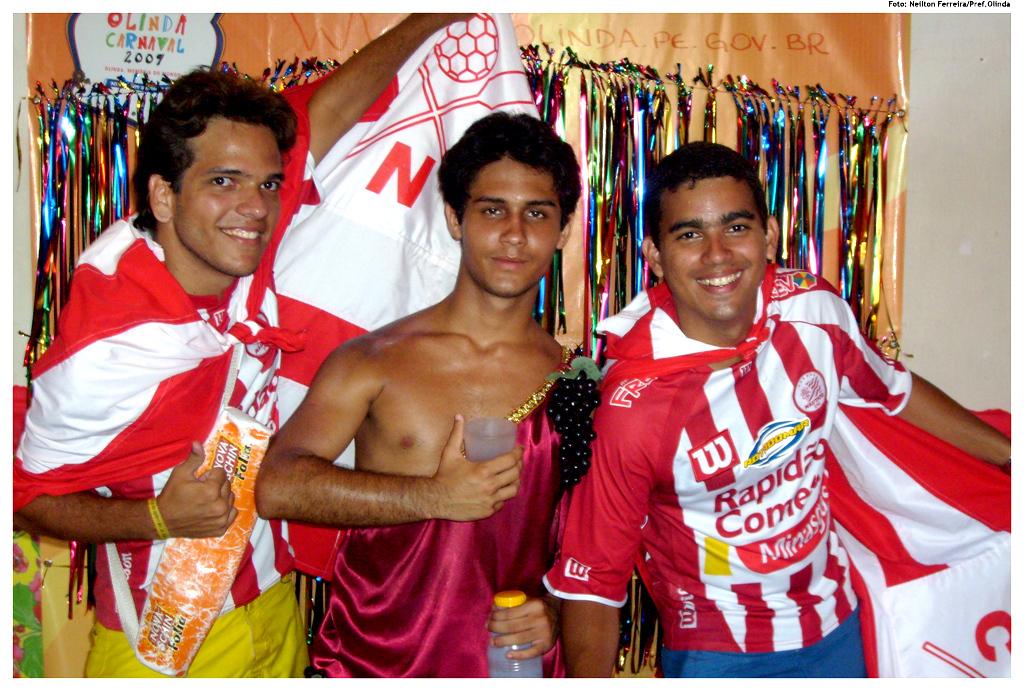Are these soccer players?
Keep it short and to the point. Yes. What is the brand written on the jersey of the man on the right?
Offer a very short reply. Rapid come. 